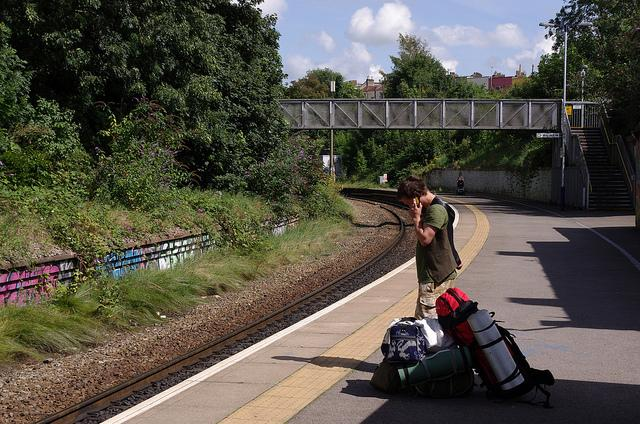If you had to cross to the other side how would you do it? walk 